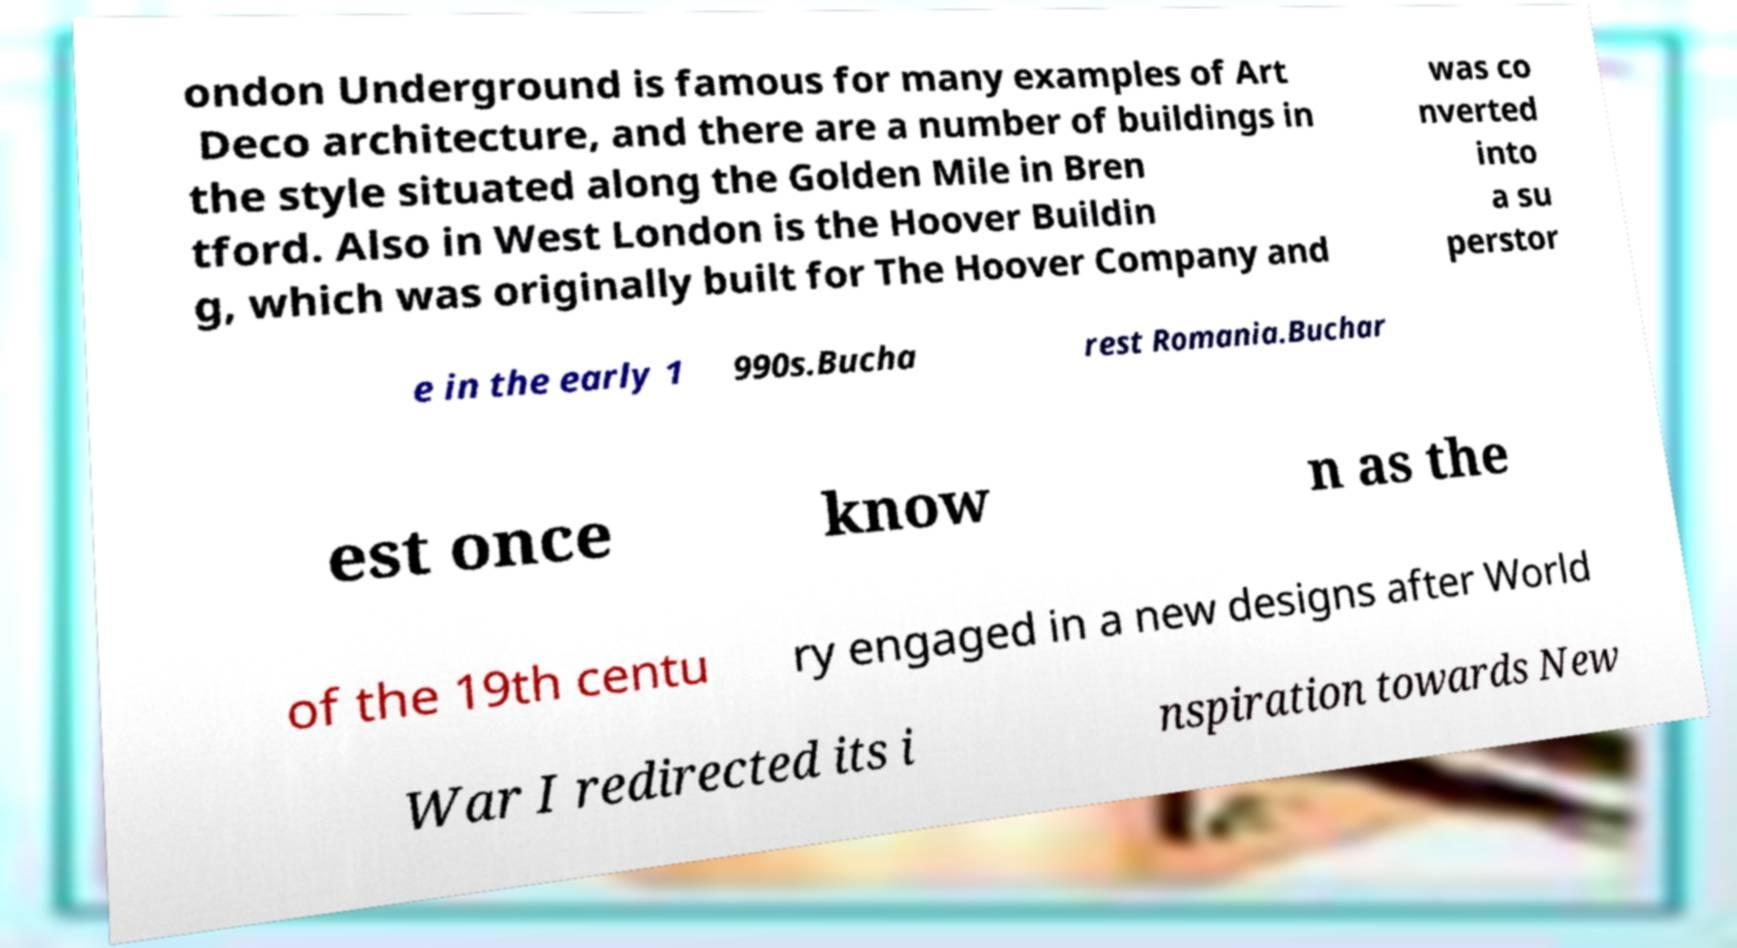There's text embedded in this image that I need extracted. Can you transcribe it verbatim? ondon Underground is famous for many examples of Art Deco architecture, and there are a number of buildings in the style situated along the Golden Mile in Bren tford. Also in West London is the Hoover Buildin g, which was originally built for The Hoover Company and was co nverted into a su perstor e in the early 1 990s.Bucha rest Romania.Buchar est once know n as the of the 19th centu ry engaged in a new designs after World War I redirected its i nspiration towards New 